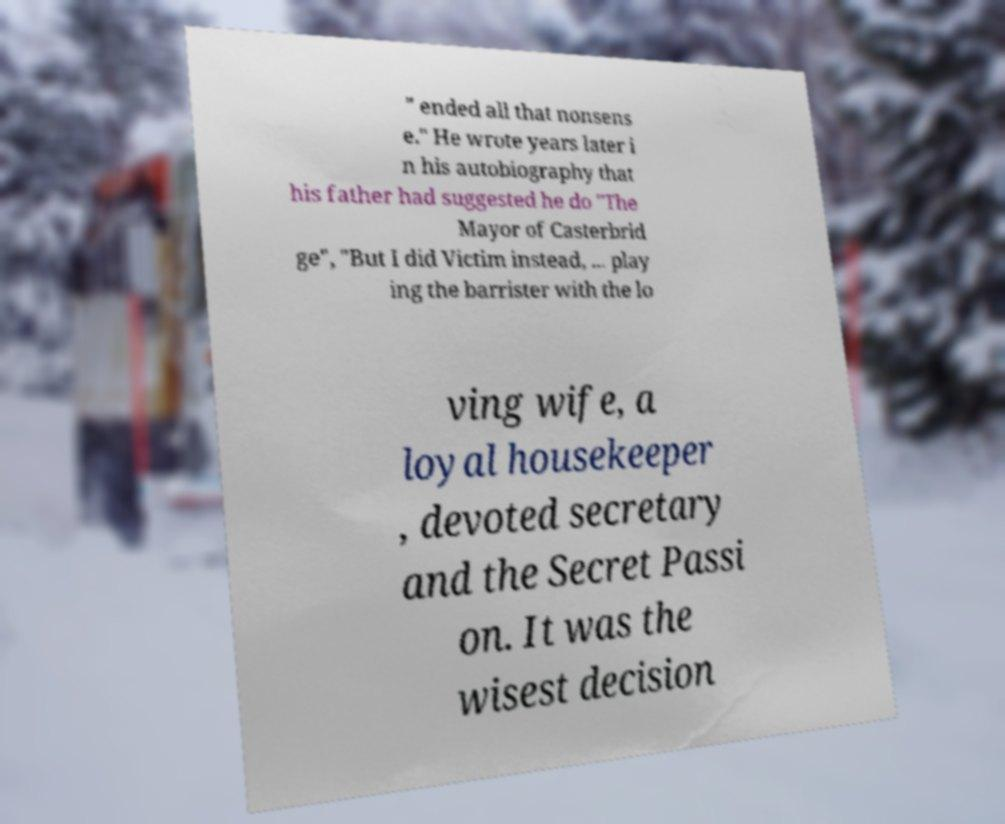Can you accurately transcribe the text from the provided image for me? " ended all that nonsens e." He wrote years later i n his autobiography that his father had suggested he do "The Mayor of Casterbrid ge", "But I did Victim instead, ... play ing the barrister with the lo ving wife, a loyal housekeeper , devoted secretary and the Secret Passi on. It was the wisest decision 